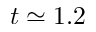<formula> <loc_0><loc_0><loc_500><loc_500>t \simeq 1 . 2</formula> 